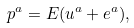<formula> <loc_0><loc_0><loc_500><loc_500>p ^ { a } = E ( u ^ { a } + e ^ { a } ) ,</formula> 